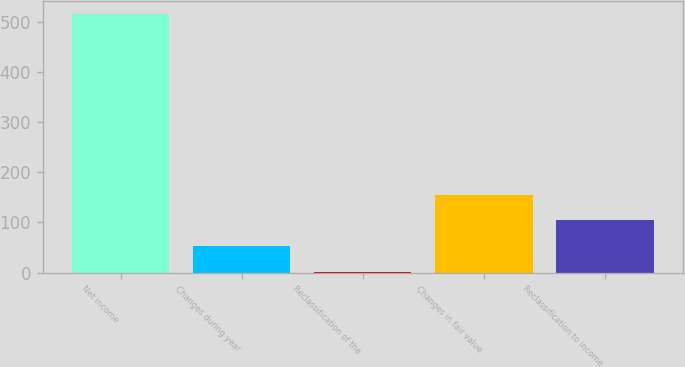<chart> <loc_0><loc_0><loc_500><loc_500><bar_chart><fcel>Net income<fcel>Changes during year<fcel>Reclassification of the<fcel>Changes in fair value<fcel>Reclassification to income<nl><fcel>516<fcel>52.5<fcel>1<fcel>155.5<fcel>104<nl></chart> 